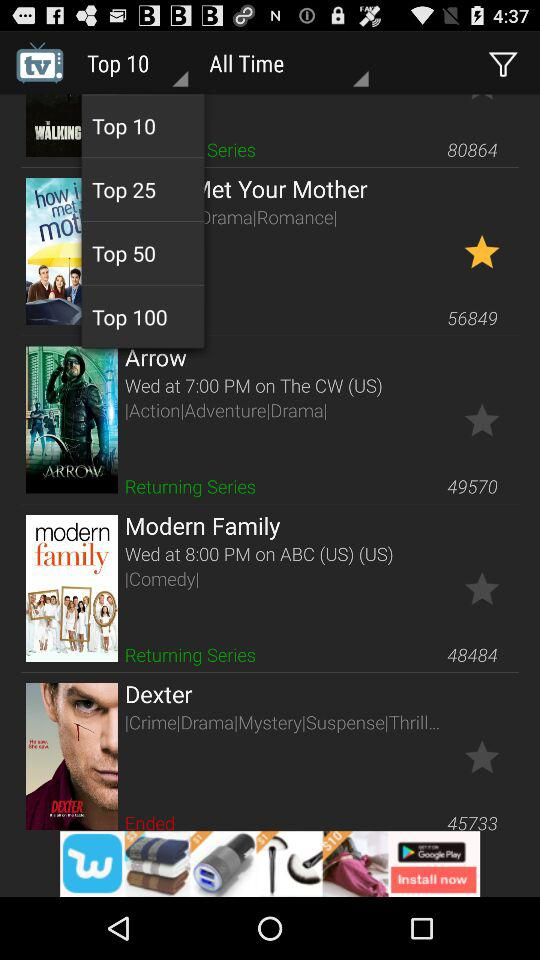Which series is selected as favourite?
When the provided information is insufficient, respond with <no answer>. <no answer> 